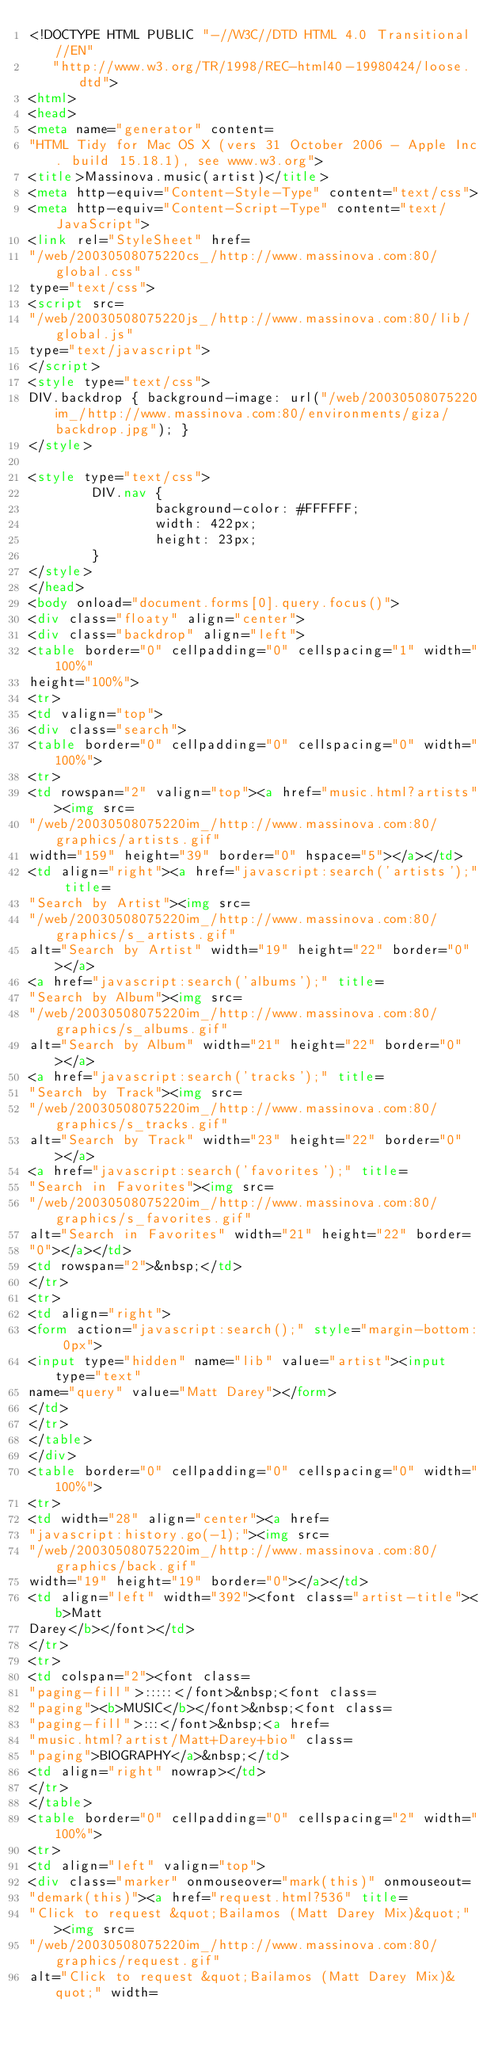Convert code to text. <code><loc_0><loc_0><loc_500><loc_500><_HTML_><!DOCTYPE HTML PUBLIC "-//W3C//DTD HTML 4.0 Transitional//EN"
   "http://www.w3.org/TR/1998/REC-html40-19980424/loose.dtd">
<html>
<head>
<meta name="generator" content=
"HTML Tidy for Mac OS X (vers 31 October 2006 - Apple Inc. build 15.18.1), see www.w3.org">
<title>Massinova.music(artist)</title>
<meta http-equiv="Content-Style-Type" content="text/css">
<meta http-equiv="Content-Script-Type" content="text/JavaScript">
<link rel="StyleSheet" href=
"/web/20030508075220cs_/http://www.massinova.com:80/global.css"
type="text/css">
<script src=
"/web/20030508075220js_/http://www.massinova.com:80/lib/global.js"
type="text/javascript">
</script>
<style type="text/css">
DIV.backdrop { background-image: url("/web/20030508075220im_/http://www.massinova.com:80/environments/giza/backdrop.jpg"); }
</style>

<style type="text/css">
        DIV.nav {
                background-color: #FFFFFF; 
                width: 422px;
                height: 23px;
        }
</style>
</head>
<body onload="document.forms[0].query.focus()">
<div class="floaty" align="center">
<div class="backdrop" align="left">
<table border="0" cellpadding="0" cellspacing="1" width="100%"
height="100%">
<tr>
<td valign="top">
<div class="search">
<table border="0" cellpadding="0" cellspacing="0" width="100%">
<tr>
<td rowspan="2" valign="top"><a href="music.html?artists"><img src=
"/web/20030508075220im_/http://www.massinova.com:80/graphics/artists.gif"
width="159" height="39" border="0" hspace="5"></a></td>
<td align="right"><a href="javascript:search('artists');" title=
"Search by Artist"><img src=
"/web/20030508075220im_/http://www.massinova.com:80/graphics/s_artists.gif"
alt="Search by Artist" width="19" height="22" border="0"></a>
<a href="javascript:search('albums');" title=
"Search by Album"><img src=
"/web/20030508075220im_/http://www.massinova.com:80/graphics/s_albums.gif"
alt="Search by Album" width="21" height="22" border="0"></a>
<a href="javascript:search('tracks');" title=
"Search by Track"><img src=
"/web/20030508075220im_/http://www.massinova.com:80/graphics/s_tracks.gif"
alt="Search by Track" width="23" height="22" border="0"></a>
<a href="javascript:search('favorites');" title=
"Search in Favorites"><img src=
"/web/20030508075220im_/http://www.massinova.com:80/graphics/s_favorites.gif"
alt="Search in Favorites" width="21" height="22" border=
"0"></a></td>
<td rowspan="2">&nbsp;</td>
</tr>
<tr>
<td align="right">
<form action="javascript:search();" style="margin-bottom: 0px">
<input type="hidden" name="lib" value="artist"><input type="text"
name="query" value="Matt Darey"></form>
</td>
</tr>
</table>
</div>
<table border="0" cellpadding="0" cellspacing="0" width="100%">
<tr>
<td width="28" align="center"><a href=
"javascript:history.go(-1);"><img src=
"/web/20030508075220im_/http://www.massinova.com:80/graphics/back.gif"
width="19" height="19" border="0"></a></td>
<td align="left" width="392"><font class="artist-title"><b>Matt
Darey</b></font></td>
</tr>
<tr>
<td colspan="2"><font class=
"paging-fill">:::::</font>&nbsp;<font class=
"paging"><b>MUSIC</b></font>&nbsp;<font class=
"paging-fill">:::</font>&nbsp;<a href=
"music.html?artist/Matt+Darey+bio" class=
"paging">BIOGRAPHY</a>&nbsp;</td>
<td align="right" nowrap></td>
</tr>
</table>
<table border="0" cellpadding="0" cellspacing="2" width="100%">
<tr>
<td align="left" valign="top">
<div class="marker" onmouseover="mark(this)" onmouseout=
"demark(this)"><a href="request.html?536" title=
"Click to request &quot;Bailamos (Matt Darey Mix)&quot;"><img src=
"/web/20030508075220im_/http://www.massinova.com:80/graphics/request.gif"
alt="Click to request &quot;Bailamos (Matt Darey Mix)&quot;" width=</code> 